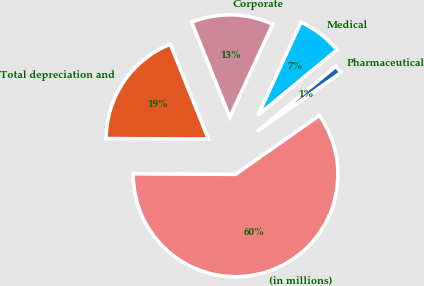Convert chart to OTSL. <chart><loc_0><loc_0><loc_500><loc_500><pie_chart><fcel>(in millions)<fcel>Pharmaceutical<fcel>Medical<fcel>Corporate<fcel>Total depreciation and<nl><fcel>59.84%<fcel>1.25%<fcel>7.11%<fcel>12.97%<fcel>18.83%<nl></chart> 